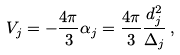Convert formula to latex. <formula><loc_0><loc_0><loc_500><loc_500>V _ { j } = - \frac { 4 \pi } { 3 } \alpha _ { j } = \frac { 4 \pi } { 3 } \frac { d _ { j } ^ { 2 } } { \Delta _ { j } } \, ,</formula> 